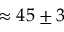Convert formula to latex. <formula><loc_0><loc_0><loc_500><loc_500>\approx 4 5 \pm 3</formula> 